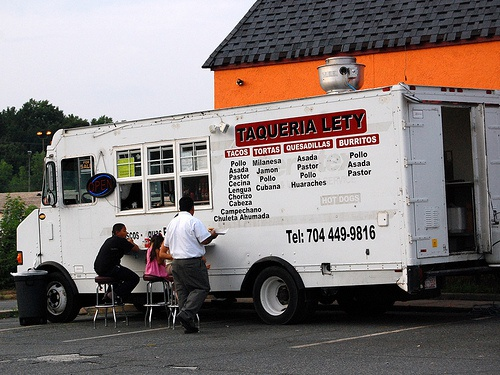Describe the objects in this image and their specific colors. I can see truck in lavender, lightgray, black, darkgray, and gray tones, people in lavender, black, and darkgray tones, people in lavender, black, maroon, gray, and darkgray tones, people in lavender, black, maroon, gray, and brown tones, and chair in lavender, black, gray, darkgray, and lightgray tones in this image. 